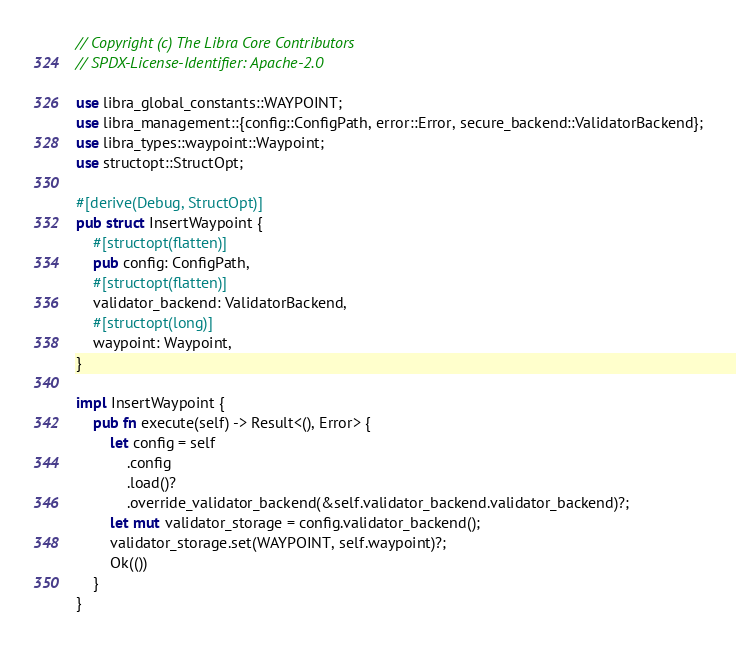Convert code to text. <code><loc_0><loc_0><loc_500><loc_500><_Rust_>// Copyright (c) The Libra Core Contributors
// SPDX-License-Identifier: Apache-2.0

use libra_global_constants::WAYPOINT;
use libra_management::{config::ConfigPath, error::Error, secure_backend::ValidatorBackend};
use libra_types::waypoint::Waypoint;
use structopt::StructOpt;

#[derive(Debug, StructOpt)]
pub struct InsertWaypoint {
    #[structopt(flatten)]
    pub config: ConfigPath,
    #[structopt(flatten)]
    validator_backend: ValidatorBackend,
    #[structopt(long)]
    waypoint: Waypoint,
}

impl InsertWaypoint {
    pub fn execute(self) -> Result<(), Error> {
        let config = self
            .config
            .load()?
            .override_validator_backend(&self.validator_backend.validator_backend)?;
        let mut validator_storage = config.validator_backend();
        validator_storage.set(WAYPOINT, self.waypoint)?;
        Ok(())
    }
}
</code> 